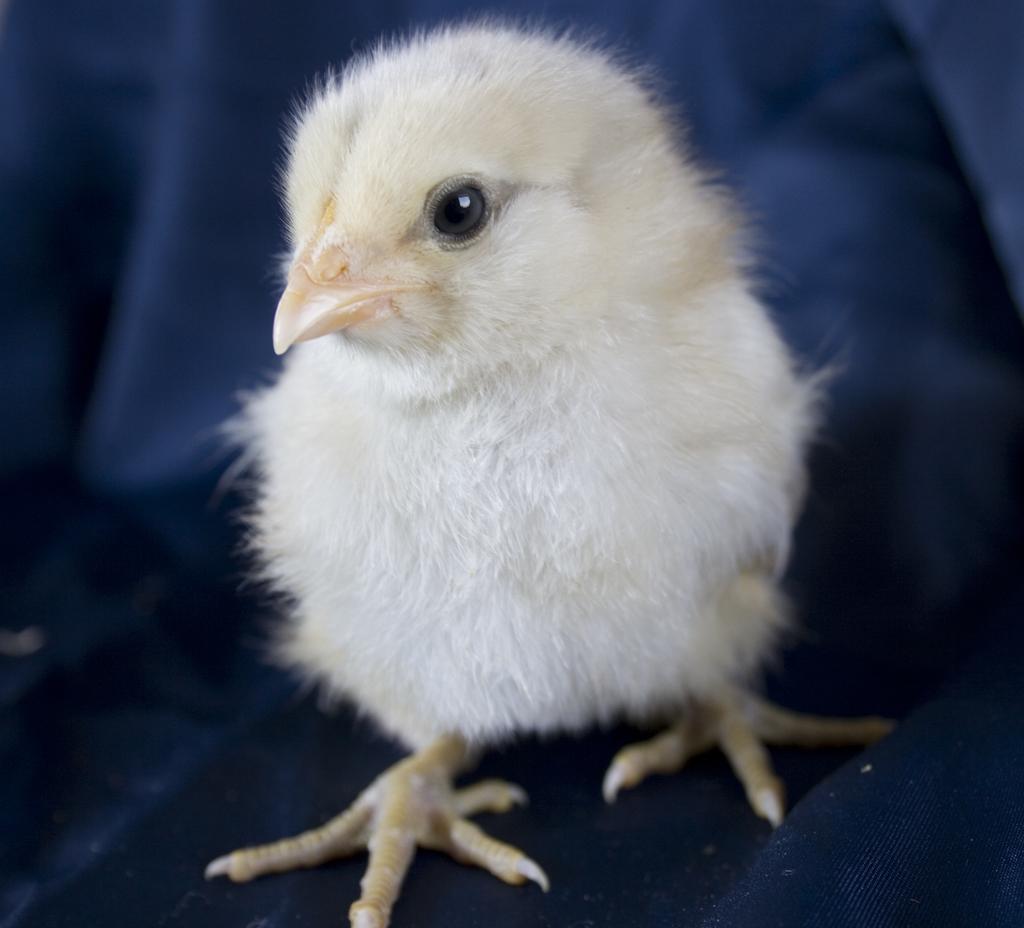Can you describe this image briefly? In this image I can see a white colour chick in the front and I can also see a cloth in the background. 